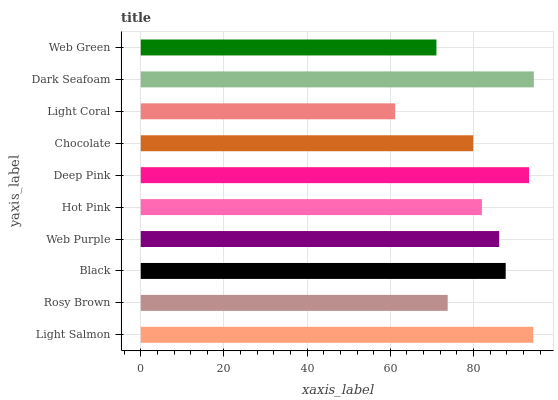Is Light Coral the minimum?
Answer yes or no. Yes. Is Dark Seafoam the maximum?
Answer yes or no. Yes. Is Rosy Brown the minimum?
Answer yes or no. No. Is Rosy Brown the maximum?
Answer yes or no. No. Is Light Salmon greater than Rosy Brown?
Answer yes or no. Yes. Is Rosy Brown less than Light Salmon?
Answer yes or no. Yes. Is Rosy Brown greater than Light Salmon?
Answer yes or no. No. Is Light Salmon less than Rosy Brown?
Answer yes or no. No. Is Web Purple the high median?
Answer yes or no. Yes. Is Hot Pink the low median?
Answer yes or no. Yes. Is Light Coral the high median?
Answer yes or no. No. Is Light Salmon the low median?
Answer yes or no. No. 